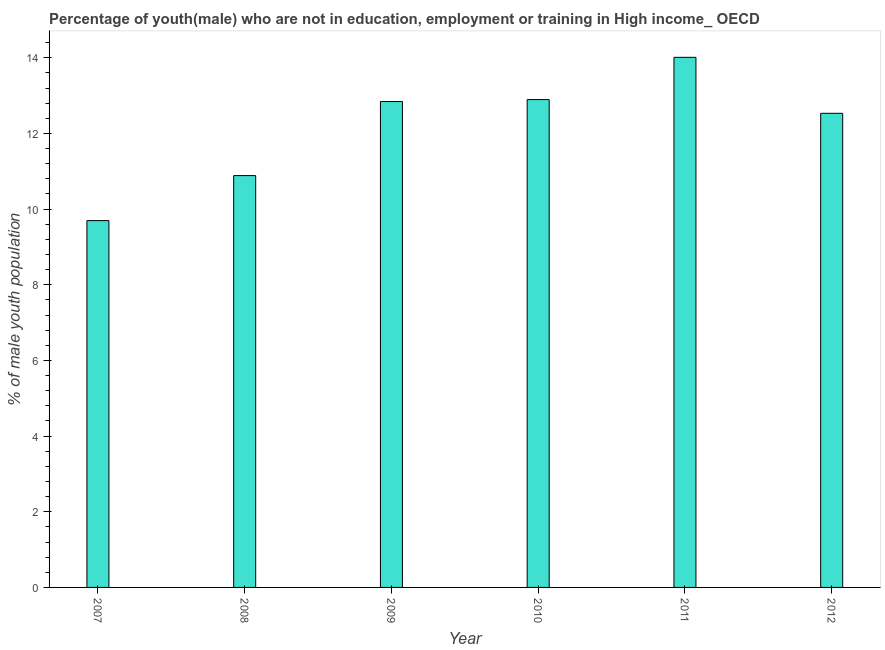Does the graph contain any zero values?
Provide a short and direct response. No. Does the graph contain grids?
Provide a succinct answer. No. What is the title of the graph?
Ensure brevity in your answer.  Percentage of youth(male) who are not in education, employment or training in High income_ OECD. What is the label or title of the Y-axis?
Provide a succinct answer. % of male youth population. What is the unemployed male youth population in 2009?
Offer a terse response. 12.84. Across all years, what is the maximum unemployed male youth population?
Provide a short and direct response. 14.01. Across all years, what is the minimum unemployed male youth population?
Your response must be concise. 9.7. In which year was the unemployed male youth population maximum?
Offer a very short reply. 2011. What is the sum of the unemployed male youth population?
Provide a short and direct response. 72.86. What is the difference between the unemployed male youth population in 2007 and 2009?
Provide a succinct answer. -3.15. What is the average unemployed male youth population per year?
Your response must be concise. 12.14. What is the median unemployed male youth population?
Keep it short and to the point. 12.69. What is the ratio of the unemployed male youth population in 2011 to that in 2012?
Make the answer very short. 1.12. What is the difference between the highest and the second highest unemployed male youth population?
Provide a short and direct response. 1.12. What is the difference between the highest and the lowest unemployed male youth population?
Give a very brief answer. 4.32. In how many years, is the unemployed male youth population greater than the average unemployed male youth population taken over all years?
Your answer should be very brief. 4. How many bars are there?
Ensure brevity in your answer.  6. Are all the bars in the graph horizontal?
Ensure brevity in your answer.  No. What is the difference between two consecutive major ticks on the Y-axis?
Give a very brief answer. 2. Are the values on the major ticks of Y-axis written in scientific E-notation?
Provide a short and direct response. No. What is the % of male youth population of 2007?
Give a very brief answer. 9.7. What is the % of male youth population of 2008?
Your response must be concise. 10.89. What is the % of male youth population in 2009?
Your answer should be very brief. 12.84. What is the % of male youth population in 2010?
Keep it short and to the point. 12.89. What is the % of male youth population in 2011?
Provide a succinct answer. 14.01. What is the % of male youth population in 2012?
Provide a short and direct response. 12.53. What is the difference between the % of male youth population in 2007 and 2008?
Provide a succinct answer. -1.19. What is the difference between the % of male youth population in 2007 and 2009?
Provide a succinct answer. -3.15. What is the difference between the % of male youth population in 2007 and 2010?
Ensure brevity in your answer.  -3.2. What is the difference between the % of male youth population in 2007 and 2011?
Provide a succinct answer. -4.32. What is the difference between the % of male youth population in 2007 and 2012?
Your response must be concise. -2.84. What is the difference between the % of male youth population in 2008 and 2009?
Offer a terse response. -1.96. What is the difference between the % of male youth population in 2008 and 2010?
Your response must be concise. -2.01. What is the difference between the % of male youth population in 2008 and 2011?
Your answer should be compact. -3.13. What is the difference between the % of male youth population in 2008 and 2012?
Your answer should be compact. -1.65. What is the difference between the % of male youth population in 2009 and 2010?
Your answer should be very brief. -0.05. What is the difference between the % of male youth population in 2009 and 2011?
Provide a succinct answer. -1.17. What is the difference between the % of male youth population in 2009 and 2012?
Offer a terse response. 0.31. What is the difference between the % of male youth population in 2010 and 2011?
Make the answer very short. -1.12. What is the difference between the % of male youth population in 2010 and 2012?
Provide a short and direct response. 0.36. What is the difference between the % of male youth population in 2011 and 2012?
Provide a succinct answer. 1.48. What is the ratio of the % of male youth population in 2007 to that in 2008?
Your answer should be very brief. 0.89. What is the ratio of the % of male youth population in 2007 to that in 2009?
Make the answer very short. 0.76. What is the ratio of the % of male youth population in 2007 to that in 2010?
Your answer should be compact. 0.75. What is the ratio of the % of male youth population in 2007 to that in 2011?
Ensure brevity in your answer.  0.69. What is the ratio of the % of male youth population in 2007 to that in 2012?
Provide a succinct answer. 0.77. What is the ratio of the % of male youth population in 2008 to that in 2009?
Your answer should be very brief. 0.85. What is the ratio of the % of male youth population in 2008 to that in 2010?
Offer a terse response. 0.84. What is the ratio of the % of male youth population in 2008 to that in 2011?
Your answer should be very brief. 0.78. What is the ratio of the % of male youth population in 2008 to that in 2012?
Offer a terse response. 0.87. What is the ratio of the % of male youth population in 2009 to that in 2010?
Your answer should be compact. 1. What is the ratio of the % of male youth population in 2009 to that in 2011?
Offer a very short reply. 0.92. What is the ratio of the % of male youth population in 2011 to that in 2012?
Your answer should be compact. 1.12. 